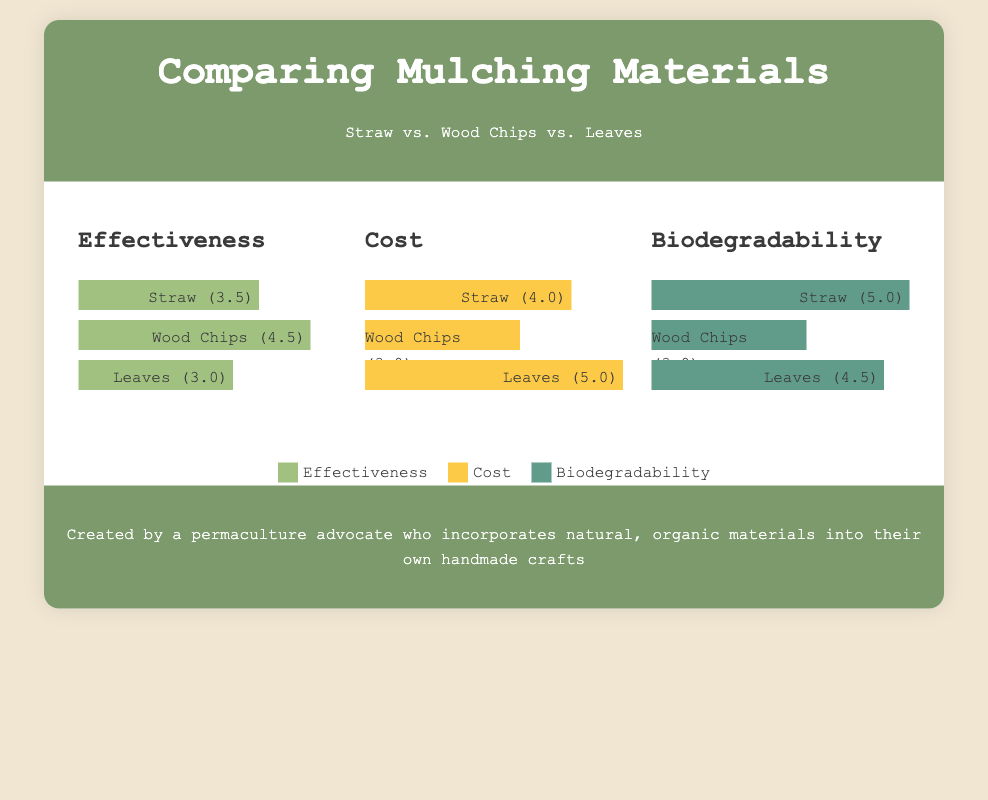What is the effectiveness score for Wood Chips? The effectiveness score for Wood Chips is indicated in the bar representing its effectiveness, which shows a value of 4.5.
Answer: 4.5 Which mulching material has the highest cost score? The highest cost score is represented by the Leaves bar, which shows a value of 5.0, the maximum in that category.
Answer: Leaves What is the biodegradability score of Straw? The biodegradability score for Straw is shown to be 5.0 in the corresponding bar for biodegradability.
Answer: 5.0 Which material is the least effective according to the infographic? The least effective material is indicated by the Leaves bar, which has the lowest effectiveness score of 3.0 among the three materials.
Answer: Leaves How many points does Wood Chips score in the cost category? The cost score for Wood Chips is displayed in the corresponding bar, which shows a value of 3.0.
Answer: 3.0 What percentage width represents the effectiveness of Straw in the chart? The effectiveness bar for Straw has a width of 70%, which represents its effectiveness visually.
Answer: 70% Which color represents the biodegradability category in the legend? The color representing biodegradability in the legend is shown as a shade of green that corresponds to the bars in that category.
Answer: Green What is the total effectiveness score sum of all three materials? The effectiveness scores are: Straw (3.5) + Wood Chips (4.5) + Leaves (3.0) which totals to 11.0.
Answer: 11.0 What is the average biodegradability score of the mulching materials? The average biodegradable score is calculated by summing the individual scores (5.0 + 3.0 + 4.5) and dividing by 3, which results in 4.2.
Answer: 4.2 